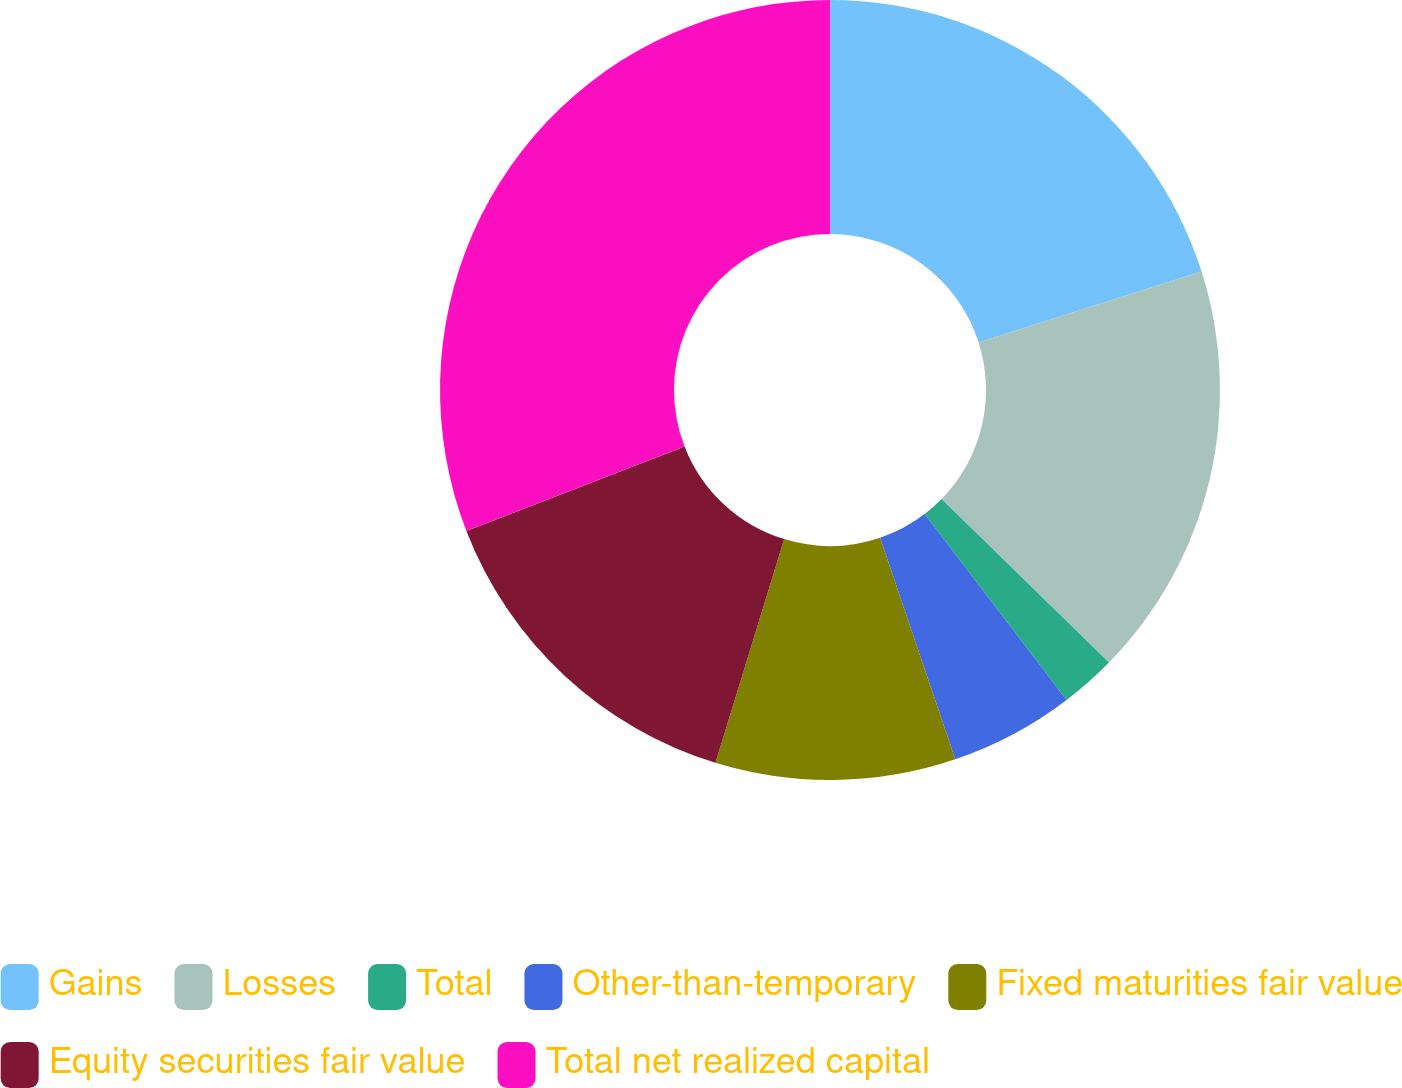Convert chart. <chart><loc_0><loc_0><loc_500><loc_500><pie_chart><fcel>Gains<fcel>Losses<fcel>Total<fcel>Other-than-temporary<fcel>Fixed maturities fair value<fcel>Equity securities fair value<fcel>Total net realized capital<nl><fcel>20.09%<fcel>17.23%<fcel>2.31%<fcel>5.17%<fcel>9.95%<fcel>14.37%<fcel>30.89%<nl></chart> 